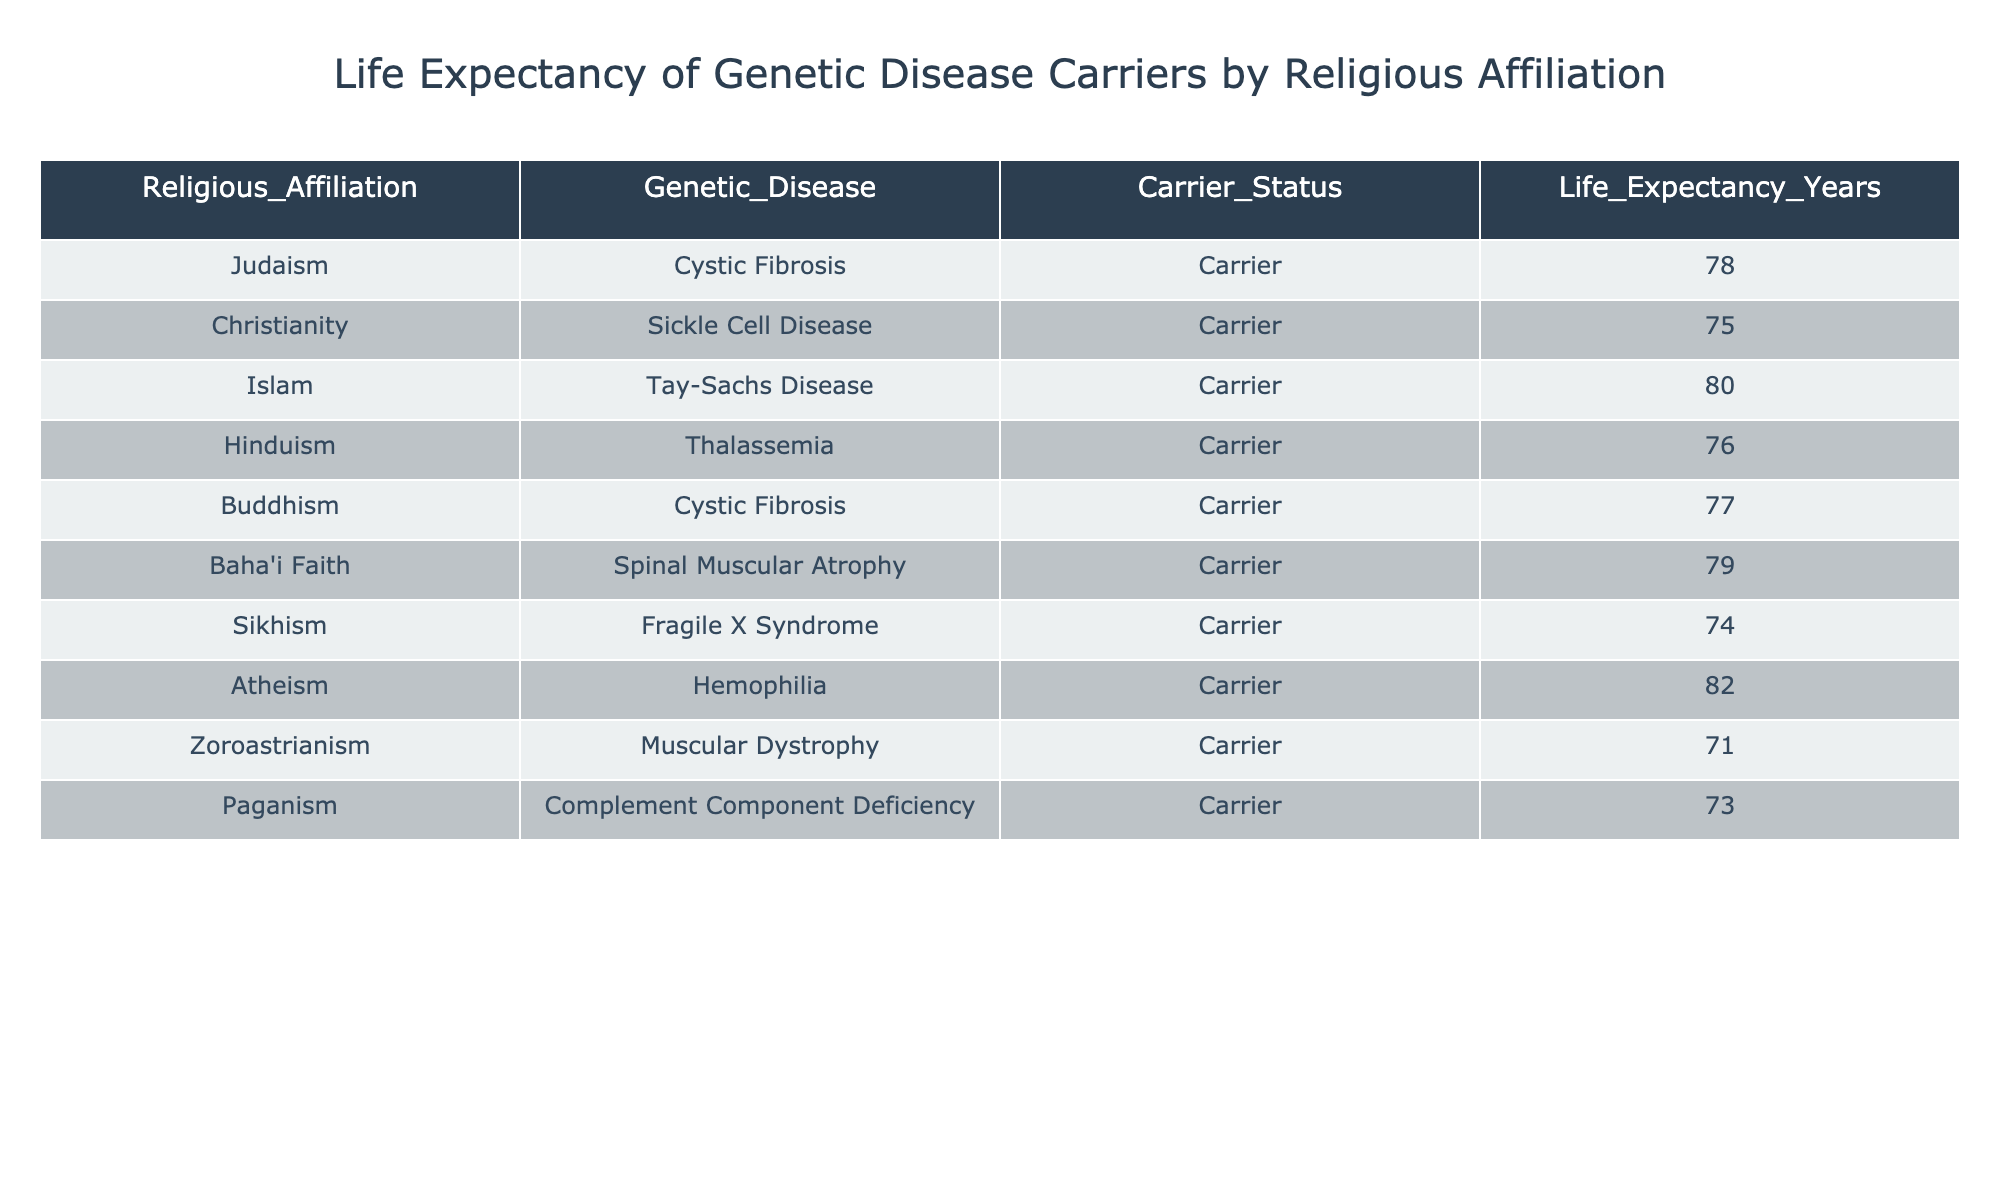What is the life expectancy of Cystic Fibrosis carriers in Judaism? The table shows that the life expectancy for Cystic Fibrosis carriers within Judaism is specifically 78 years.
Answer: 78 years Which religious affiliation has the highest life expectancy for genetic disease carriers? By examining the life expectancy values in the table, Atheism has the highest life expectancy at 82 years.
Answer: Atheism Is the life expectancy of Sickle Cell Disease carriers higher than that of Thalassemia carriers? The life expectancy for Sickle Cell Disease carriers in Christianity is 75 years, while Thalassemia carriers in Hinduism have a life expectancy of 76 years. Since 76 is greater than 75, Sickle Cell Disease carriers do not have a higher life expectancy.
Answer: No What is the average life expectancy of genetic disease carriers among the listed religious affiliations? The life expectancies are 78, 75, 80, 76, 77, 79, 74, 82, 71, and 73. Summing these values gives  78 + 75 + 80 + 76 + 77 + 79 + 74 + 82 + 71 + 73 =  79. The total number of religious affiliations is 10, so the average is 790/10 = 79.
Answer: 79 Do both Hinduism and Buddhism have a life expectancy of over 75 years for genetic disease carriers? Hinduism has a life expectancy of 76 years for Thalassemia carriers, while Buddhism has a life expectancy of 77 years for Cystic Fibrosis carriers. Both values are above 75 years, confirming the statement.
Answer: Yes How many religious affiliations have a life expectancy less than 75 years? The table shows that Zoroastrianism (71 years) and Sikhism (74 years) have life expectancies under 75 years. Hence, there are 2 such affiliations.
Answer: 2 What is the difference in life expectancy between Muslim carriers of Tay-Sachs Disease and Atheist carriers of Hemophilia? Tay-Sachs Disease carriers in Islam have a life expectancy of 80 years, and Hemophilia carriers in Atheism have a life expectancy of 82 years. To find the difference, we calculate 82 - 80 = 2.
Answer: 2 